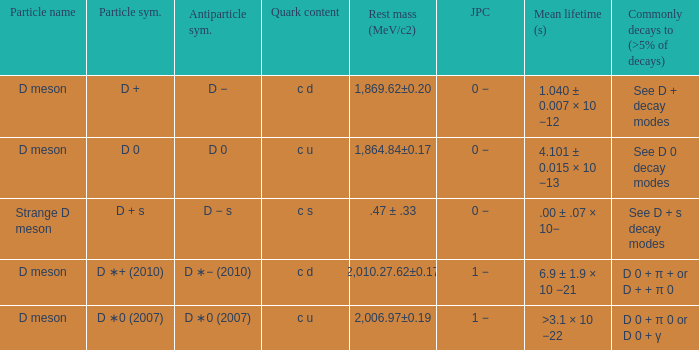What is the antiparticle symbol with a rest mess (mev/c2) of .47 ± .33? D − s. 